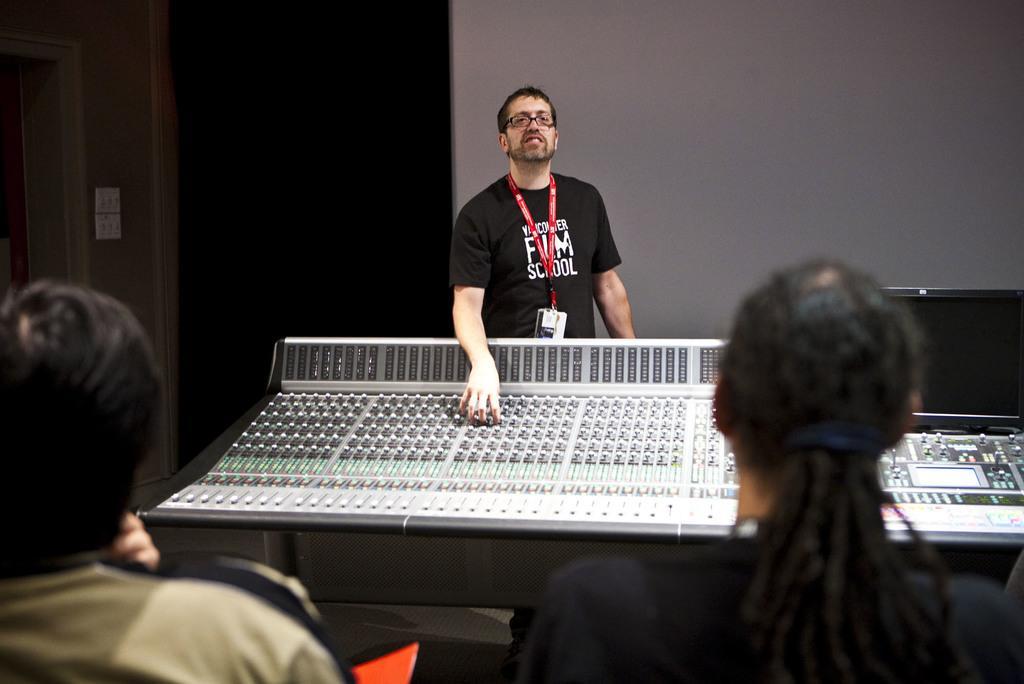In one or two sentences, can you explain what this image depicts? In this image I can see two people. Back I can see one person is standing in front the electronic device. Background is dark and I can see the wall. 